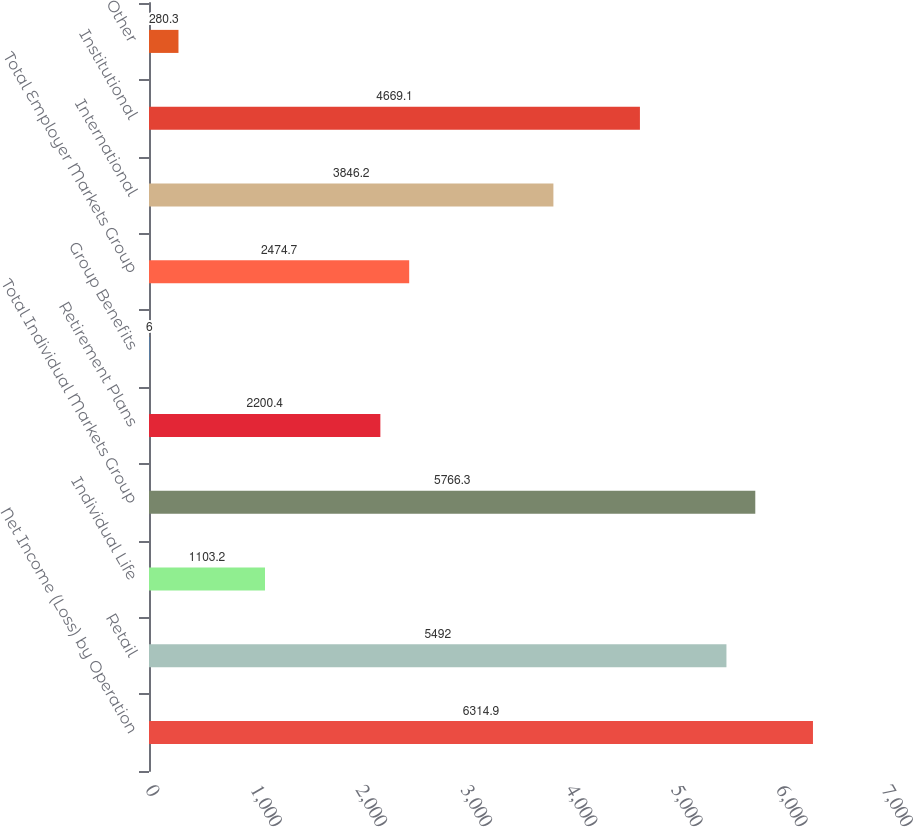Convert chart. <chart><loc_0><loc_0><loc_500><loc_500><bar_chart><fcel>Net Income (Loss) by Operation<fcel>Retail<fcel>Individual Life<fcel>Total Individual Markets Group<fcel>Retirement Plans<fcel>Group Benefits<fcel>Total Employer Markets Group<fcel>International<fcel>Institutional<fcel>Other<nl><fcel>6314.9<fcel>5492<fcel>1103.2<fcel>5766.3<fcel>2200.4<fcel>6<fcel>2474.7<fcel>3846.2<fcel>4669.1<fcel>280.3<nl></chart> 